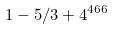<formula> <loc_0><loc_0><loc_500><loc_500>1 - 5 / 3 + 4 ^ { 4 6 6 }</formula> 